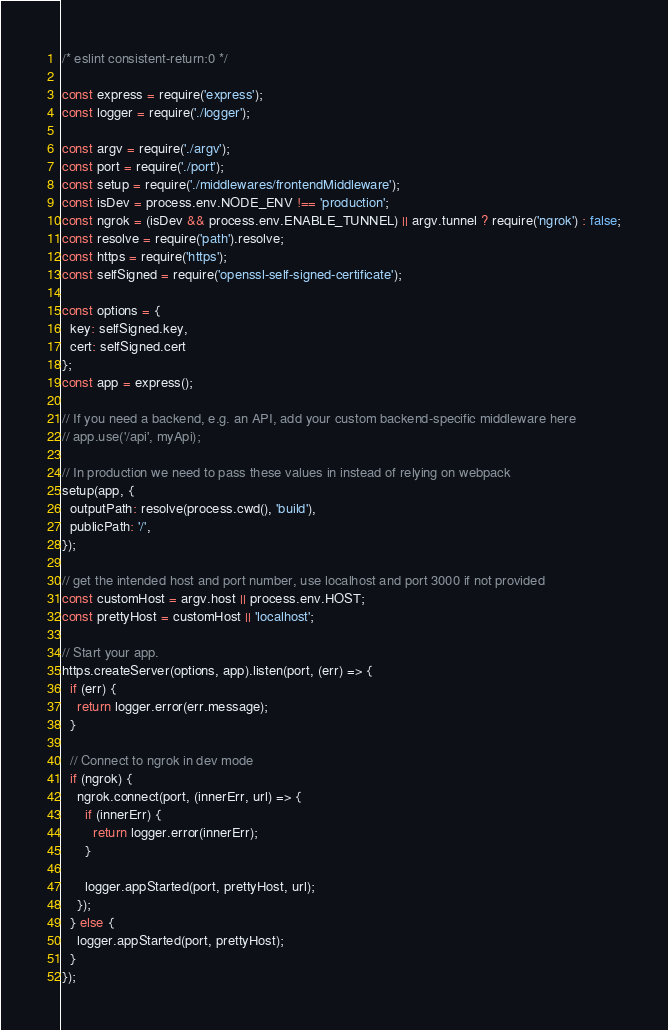Convert code to text. <code><loc_0><loc_0><loc_500><loc_500><_JavaScript_>/* eslint consistent-return:0 */

const express = require('express');
const logger = require('./logger');

const argv = require('./argv');
const port = require('./port');
const setup = require('./middlewares/frontendMiddleware');
const isDev = process.env.NODE_ENV !== 'production';
const ngrok = (isDev && process.env.ENABLE_TUNNEL) || argv.tunnel ? require('ngrok') : false;
const resolve = require('path').resolve;
const https = require('https');
const selfSigned = require('openssl-self-signed-certificate');

const options = {
  key: selfSigned.key,
  cert: selfSigned.cert
};
const app = express();

// If you need a backend, e.g. an API, add your custom backend-specific middleware here
// app.use('/api', myApi);

// In production we need to pass these values in instead of relying on webpack
setup(app, {
  outputPath: resolve(process.cwd(), 'build'),
  publicPath: '/',
});

// get the intended host and port number, use localhost and port 3000 if not provided
const customHost = argv.host || process.env.HOST;
const prettyHost = customHost || 'localhost';

// Start your app.
https.createServer(options, app).listen(port, (err) => {
  if (err) {
    return logger.error(err.message);
  }

  // Connect to ngrok in dev mode
  if (ngrok) {
    ngrok.connect(port, (innerErr, url) => {
      if (innerErr) {
        return logger.error(innerErr);
      }

      logger.appStarted(port, prettyHost, url);
    });
  } else {
    logger.appStarted(port, prettyHost);
  }
});
</code> 